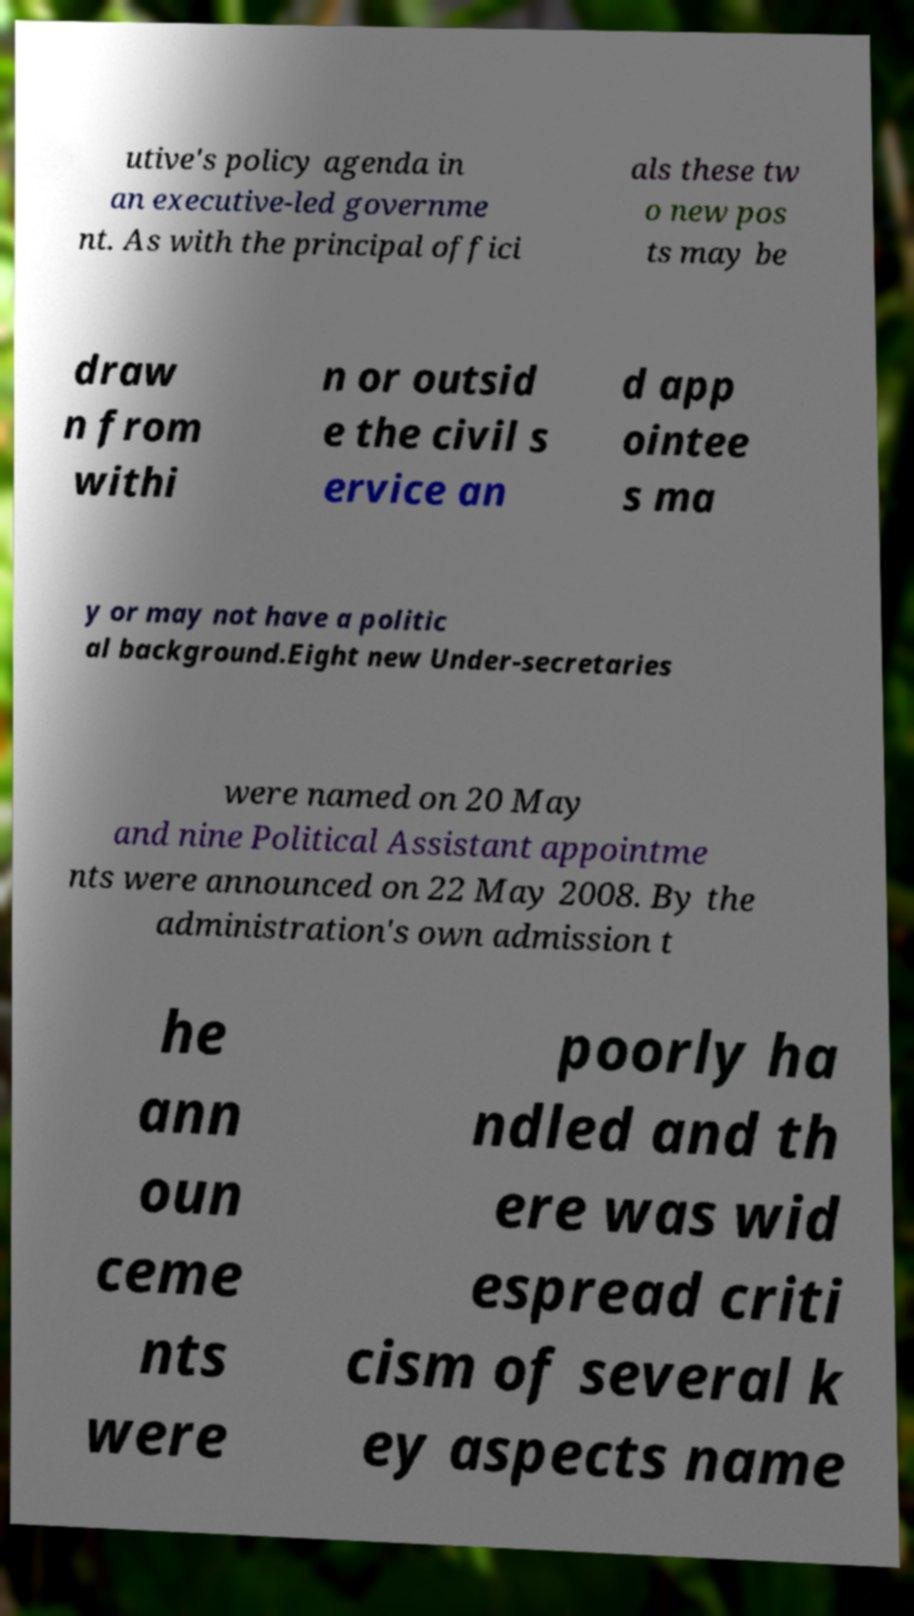I need the written content from this picture converted into text. Can you do that? utive's policy agenda in an executive-led governme nt. As with the principal offici als these tw o new pos ts may be draw n from withi n or outsid e the civil s ervice an d app ointee s ma y or may not have a politic al background.Eight new Under-secretaries were named on 20 May and nine Political Assistant appointme nts were announced on 22 May 2008. By the administration's own admission t he ann oun ceme nts were poorly ha ndled and th ere was wid espread criti cism of several k ey aspects name 